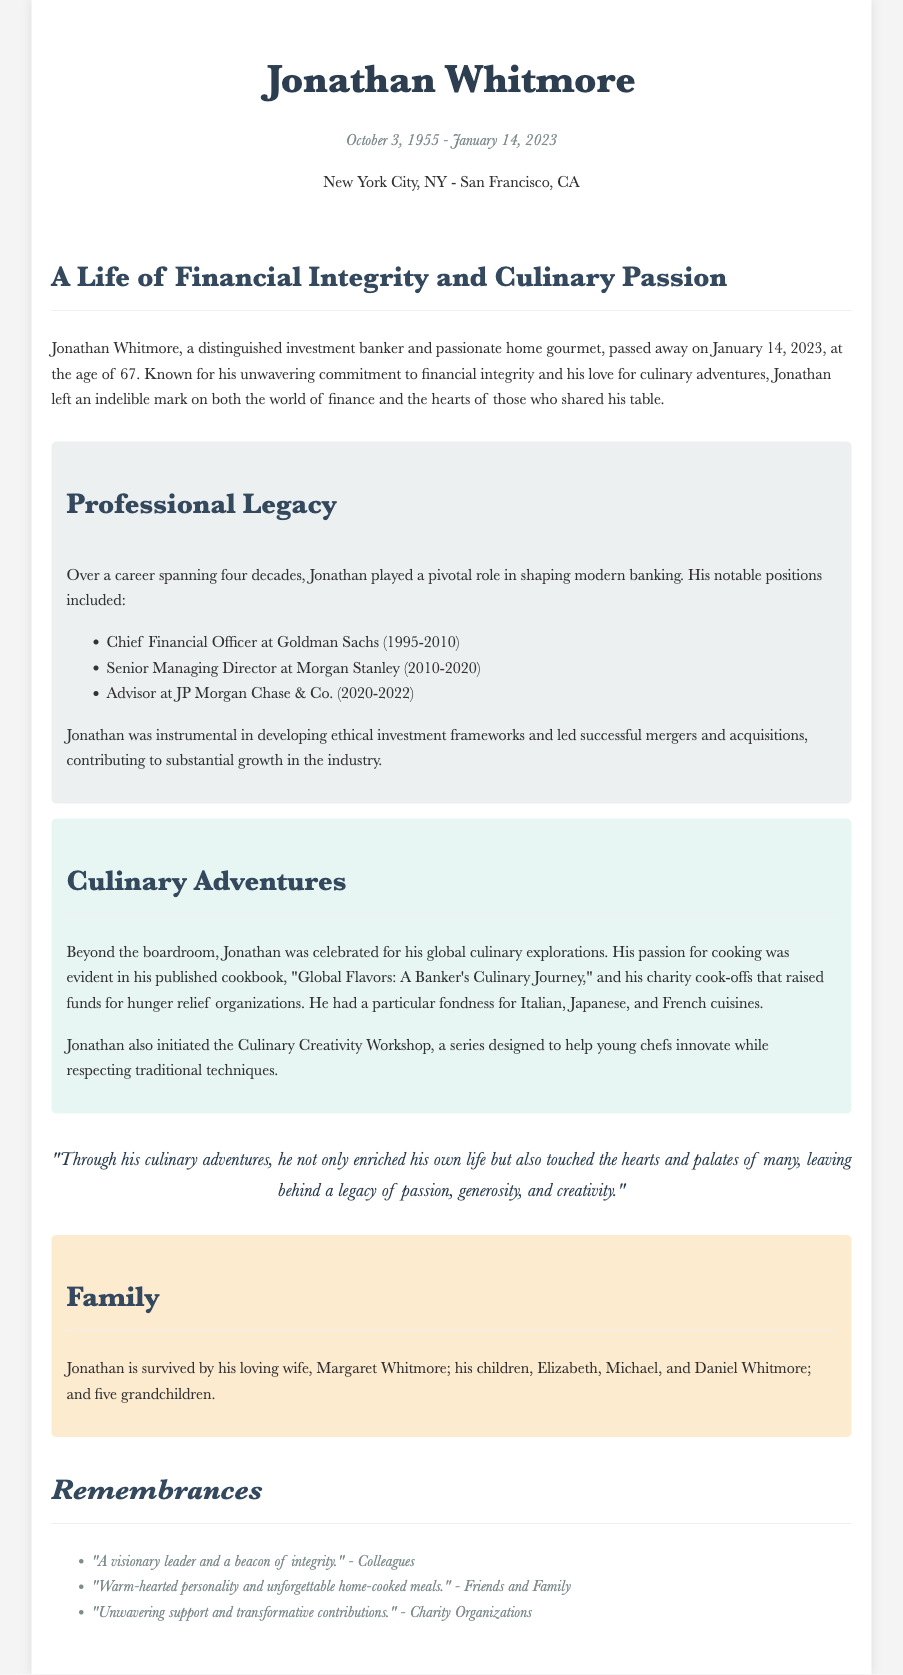What was Jonathan Whitmore's profession? The document explicitly states that Jonathan Whitmore was a distinguished investment banker.
Answer: investment banker When did Jonathan Whitmore pass away? The dates provided in the document state that he passed away on January 14, 2023.
Answer: January 14, 2023 What is the title of Jonathan's published cookbook? The document mentions his published cookbook titled "Global Flavors: A Banker's Culinary Journey."
Answer: Global Flavors: A Banker's Culinary Journey How many grandchildren did Jonathan have? The document states that he is survived by five grandchildren.
Answer: five What positions did Jonathan hold at Goldman Sachs? The document lists his role as Chief Financial Officer at Goldman Sachs from 1995 to 2010, indicating his professional legacy.
Answer: Chief Financial Officer What was one of Jonathan's culinary passions? The document notes his particular fondness for Italian, Japanese, and French cuisines.
Answer: Italian, Japanese, and French cuisines How long was Jonathan's banking career? The document mentions that his career spanned over four decades.
Answer: four decades What organization benefited from Jonathan's charity cook-offs? The document states that the charity cook-offs raised funds for hunger relief organizations.
Answer: hunger relief organizations What type of workshops did Jonathan initiate? The document describes that he initiated the Culinary Creativity Workshop, designed for young chefs.
Answer: Culinary Creativity Workshop 